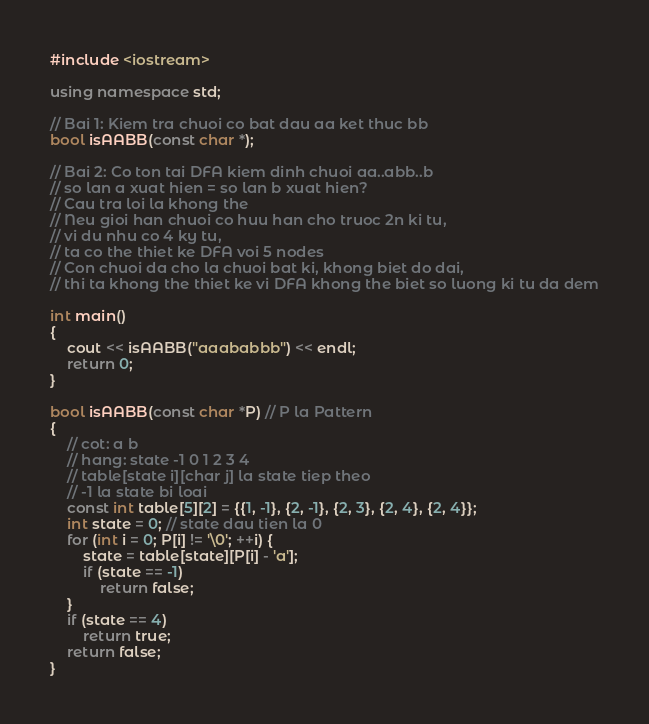Convert code to text. <code><loc_0><loc_0><loc_500><loc_500><_C++_>#include <iostream>

using namespace std;

// Bai 1: Kiem tra chuoi co bat dau aa ket thuc bb
bool isAABB(const char *);

// Bai 2: Co ton tai DFA kiem dinh chuoi aa..abb..b
// so lan a xuat hien = so lan b xuat hien?
// Cau tra loi la khong the
// Neu gioi han chuoi co huu han cho truoc 2n ki tu,
// vi du nhu co 4 ky tu,
// ta co the thiet ke DFA voi 5 nodes
// Con chuoi da cho la chuoi bat ki, khong biet do dai,
// thi ta khong the thiet ke vi DFA khong the biet so luong ki tu da dem

int main()
{
	cout << isAABB("aaababbb") << endl;
	return 0;
}

bool isAABB(const char *P) // P la Pattern
{
	// cot: a b
	// hang: state -1 0 1 2 3 4
	// table[state i][char j] la state tiep theo
	// -1 la state bi loai
	const int table[5][2] = {{1, -1}, {2, -1}, {2, 3}, {2, 4}, {2, 4}};
	int state = 0; // state dau tien la 0
	for (int i = 0; P[i] != '\0'; ++i) {
		state = table[state][P[i] - 'a'];
		if (state == -1)
			return false;
	}
	if (state == 4)
		return true;
	return false;
}
</code> 